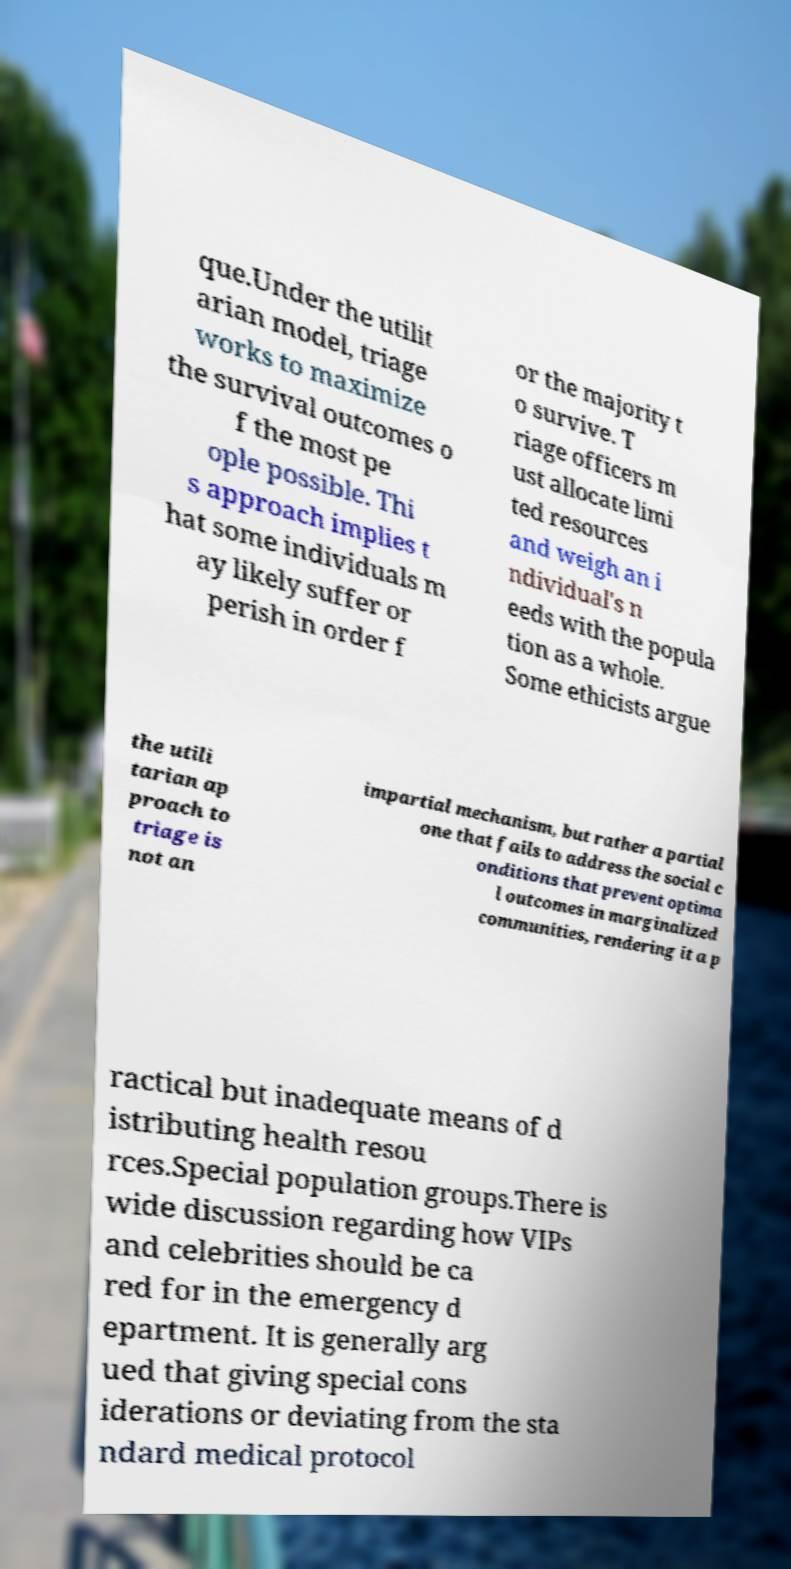For documentation purposes, I need the text within this image transcribed. Could you provide that? que.Under the utilit arian model, triage works to maximize the survival outcomes o f the most pe ople possible. Thi s approach implies t hat some individuals m ay likely suffer or perish in order f or the majority t o survive. T riage officers m ust allocate limi ted resources and weigh an i ndividual's n eeds with the popula tion as a whole. Some ethicists argue the utili tarian ap proach to triage is not an impartial mechanism, but rather a partial one that fails to address the social c onditions that prevent optima l outcomes in marginalized communities, rendering it a p ractical but inadequate means of d istributing health resou rces.Special population groups.There is wide discussion regarding how VIPs and celebrities should be ca red for in the emergency d epartment. It is generally arg ued that giving special cons iderations or deviating from the sta ndard medical protocol 